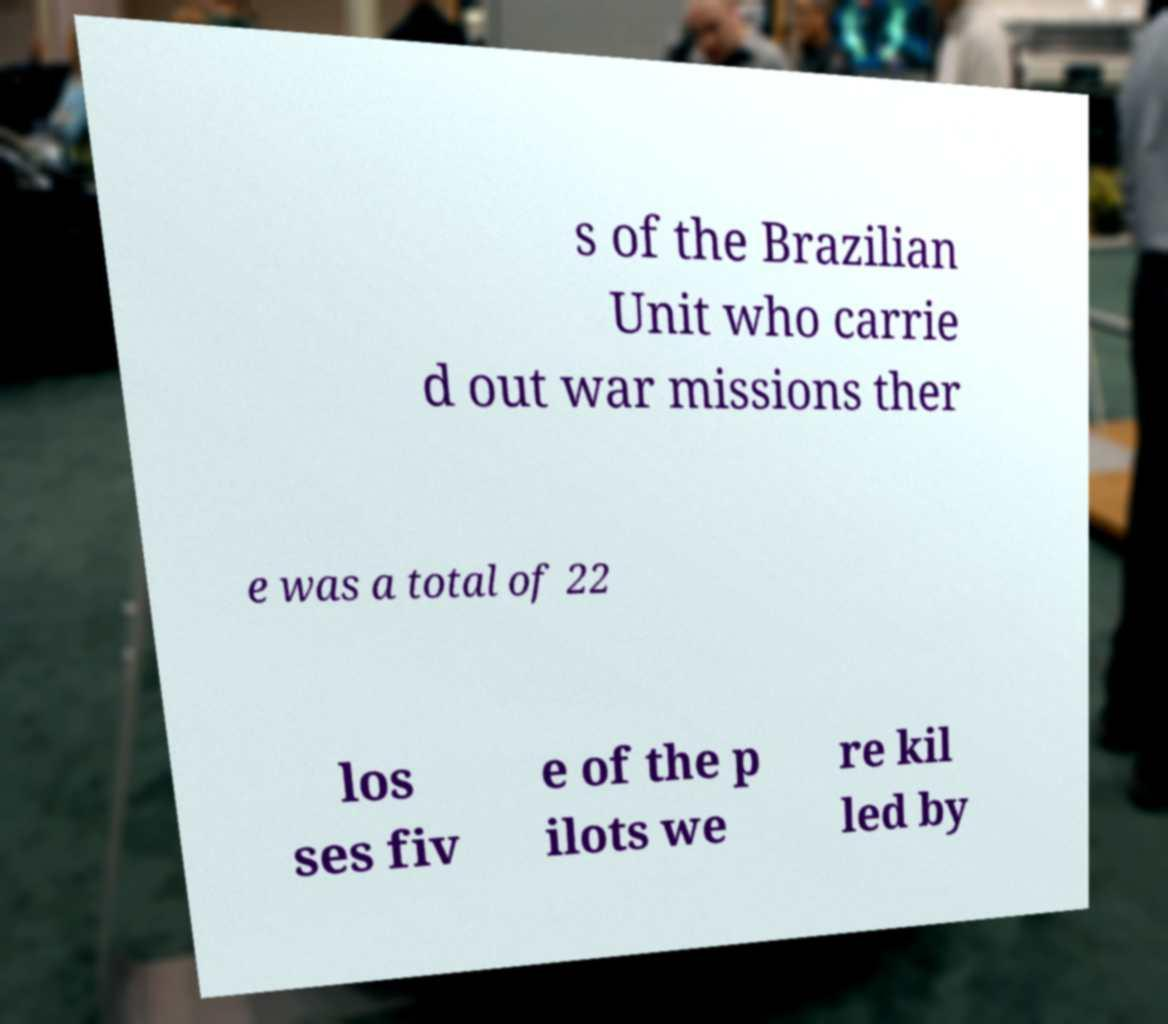Please identify and transcribe the text found in this image. s of the Brazilian Unit who carrie d out war missions ther e was a total of 22 los ses fiv e of the p ilots we re kil led by 